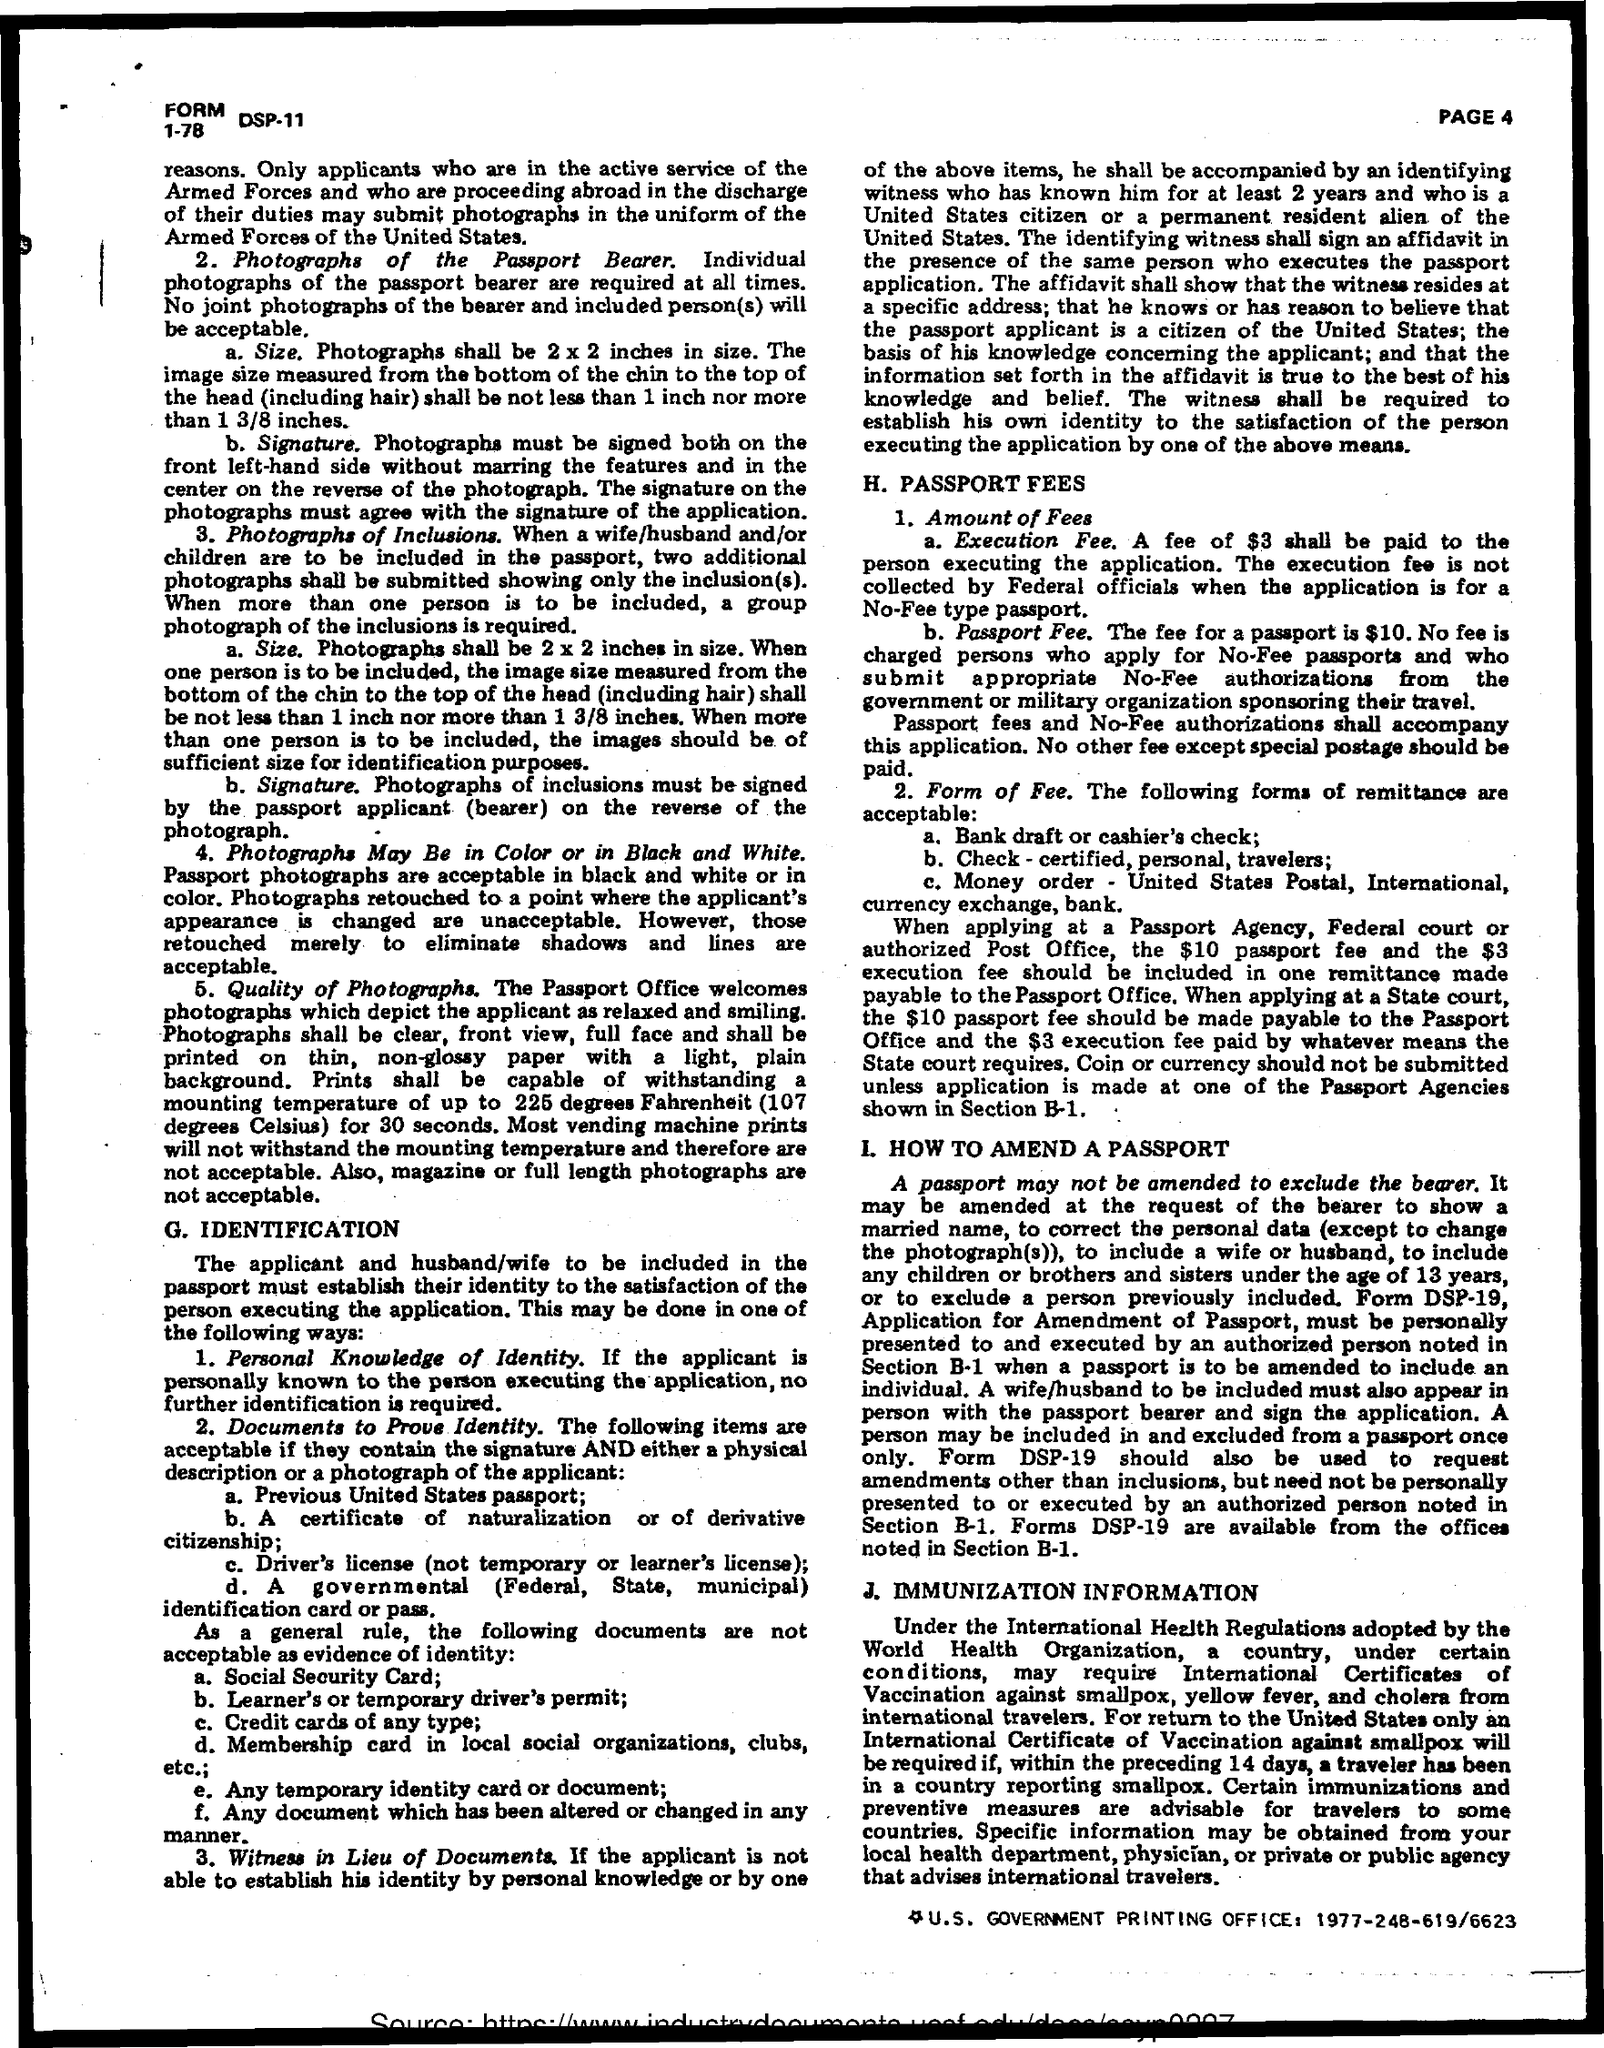What is passport fee?
Keep it short and to the point. $10. What is execution fee?
Make the answer very short. $3. 